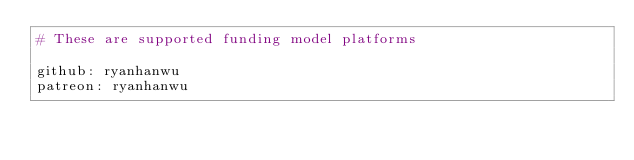Convert code to text. <code><loc_0><loc_0><loc_500><loc_500><_YAML_># These are supported funding model platforms

github: ryanhanwu
patreon: ryanhanwu
</code> 